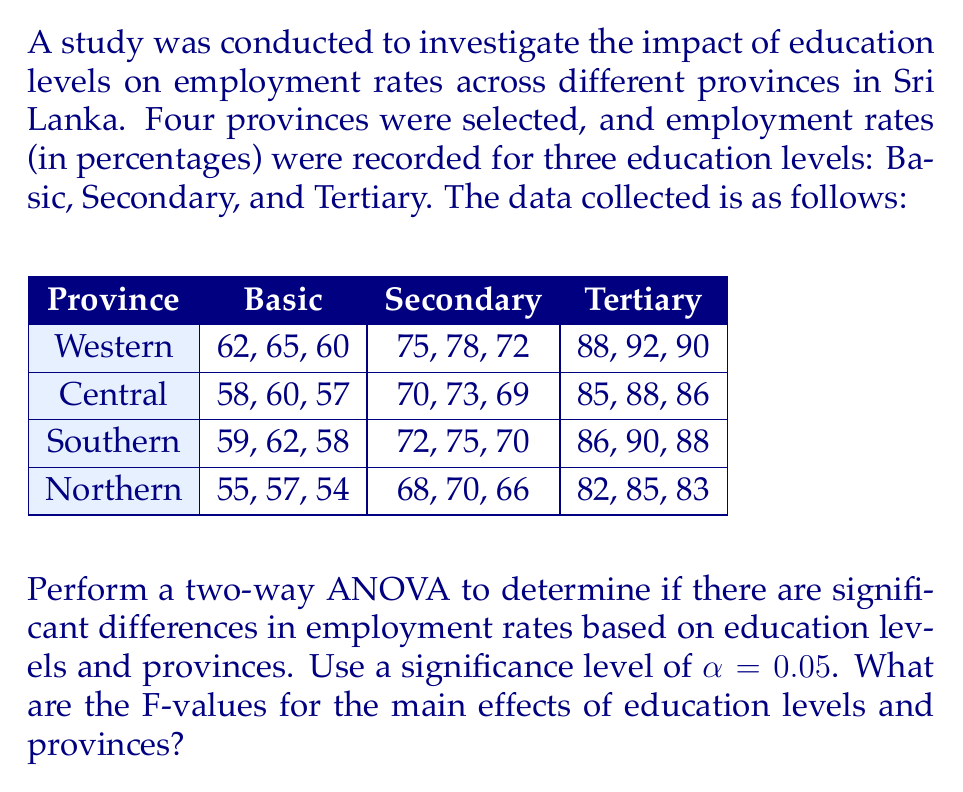Can you answer this question? To perform a two-way ANOVA, we need to calculate the following:

1. Sum of Squares for Education Levels (SSA)
2. Sum of Squares for Provinces (SSB)
3. Sum of Squares for Interaction (SSAB)
4. Sum of Squares for Error (SSE)
5. Sum of Squares Total (SST)

Step 1: Calculate the grand mean and total sum of squares

Grand mean: $\bar{X} = 72.33$
SST = 8246.67

Step 2: Calculate SSA (Education Levels)

$$SSA = 3 \times 4 \times [(59.67 - 72.33)^2 + (71.92 - 72.33)^2 + (87.42 - 72.33)^2] = 7140.22$$

Step 3: Calculate SSB (Provinces)

$$SSB = 3 \times 3 \times [(75.67 - 72.33)^2 + (71.78 - 72.33)^2 + (73.33 - 72.33)^2 + (70.56 - 72.33)^2] = 245.56$$

Step 4: Calculate SSAB (Interaction)

SSAB = 31.11

Step 5: Calculate SSE (Error)

$$SSE = SST - SSA - SSB - SSAB = 8246.67 - 7140.22 - 245.56 - 31.11 = 829.78$$

Step 6: Calculate degrees of freedom

df(A) = 2 (Education Levels - 1)
df(B) = 3 (Provinces - 1)
df(AB) = 6 (df(A) × df(B))
df(E) = 24 (Total observations - Number of groups)
df(Total) = 35 (Total observations - 1)

Step 7: Calculate Mean Squares

$$MSA = \frac{SSA}{df(A)} = 3570.11$$
$$MSB = \frac{SSB}{df(B)} = 81.85$$
$$MSAB = \frac{SSAB}{df(AB)} = 5.19$$
$$MSE = \frac{SSE}{df(E)} = 34.57$$

Step 8: Calculate F-values

$$F_A = \frac{MSA}{MSE} = \frac{3570.11}{34.57} = 103.27$$
$$F_B = \frac{MSB}{MSE} = \frac{81.85}{34.57} = 2.37$$
Answer: The F-value for the main effect of education levels is 103.27, and the F-value for the main effect of provinces is 2.37. 